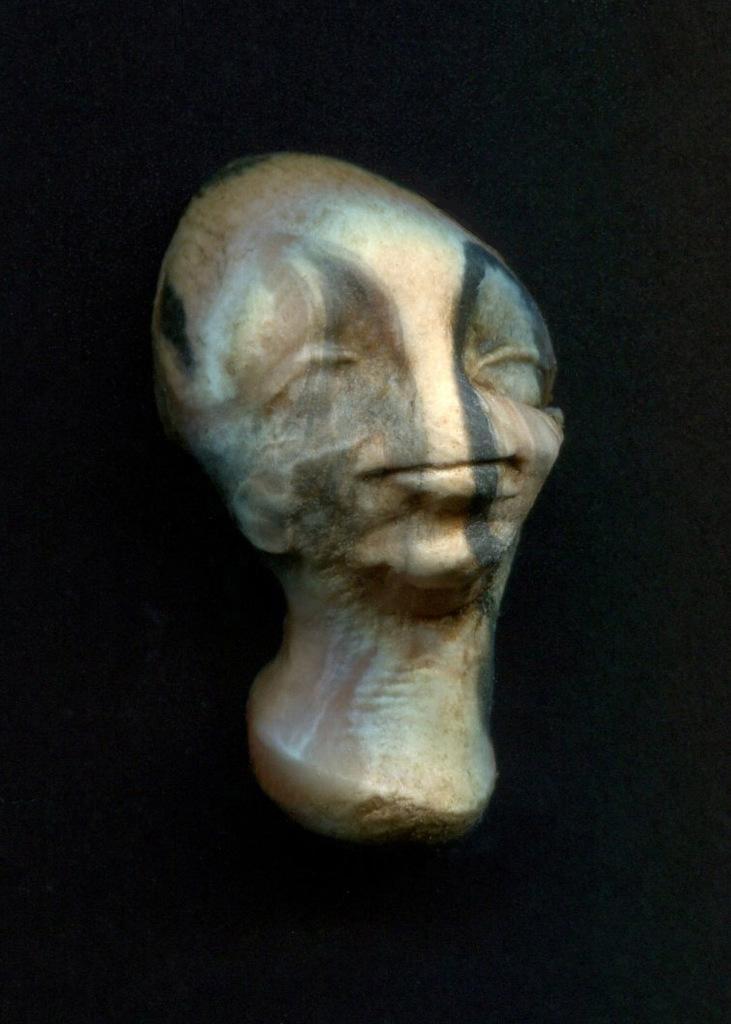Please provide a concise description of this image. In the picture I can see sculpture in the shape of a man's face. The background of the image is dark. 